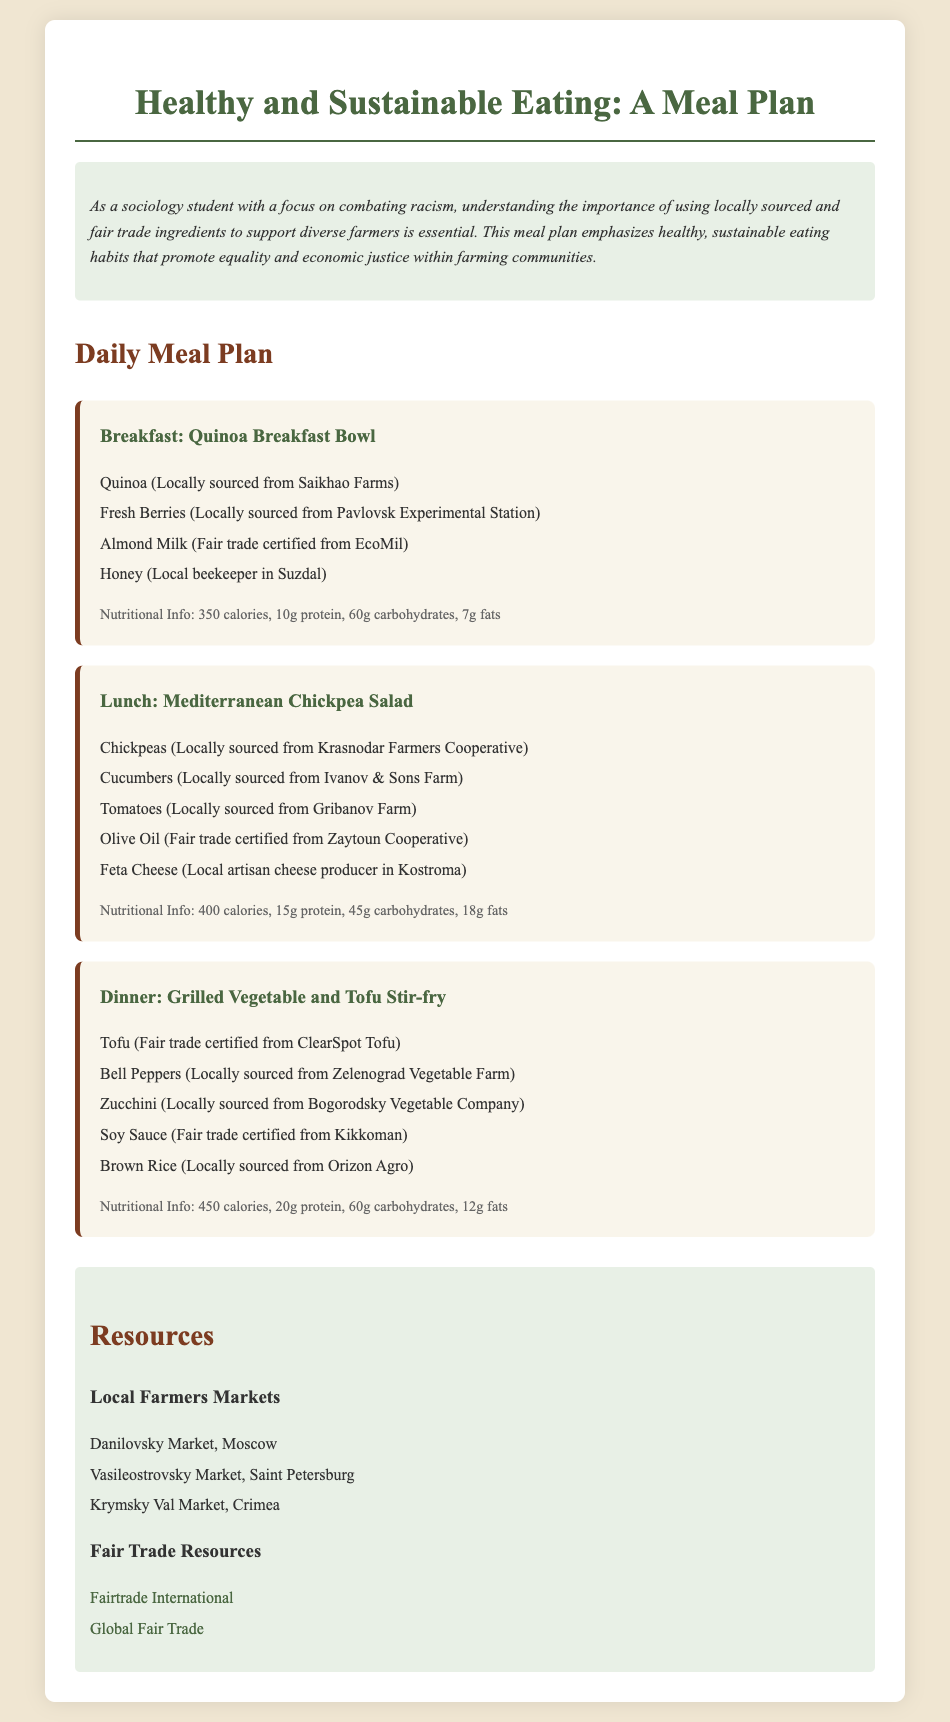What is the breakfast meal? The document specifies that the breakfast meal is a "Quinoa Breakfast Bowl."
Answer: Quinoa Breakfast Bowl Where are the chickpeas sourced from? Chickpeas are locally sourced from the "Krasnodar Farmers Cooperative."
Answer: Krasnodar Farmers Cooperative What is the total calorie content for lunch? The nutritional information states that the Mediterranean Chickpea Salad contains "400 calories."
Answer: 400 calories Which ingredient is fair trade certified in the dinner meal? The document identifies tofu as fair trade certified from "ClearSpot Tofu."
Answer: ClearSpot Tofu What type of salad is included in the lunch meal? The document describes the lunch meal as a "Mediterranean Chickpea Salad."
Answer: Mediterranean Chickpea Salad Which local farm provides the fresh berries? The fresh berries are sourced from "Pavlovsk Experimental Station."
Answer: Pavlovsk Experimental Station How many grams of protein are in the Grilled Vegetable and Tofu Stir-fry? The nutritional information indicates that it contains "20g protein."
Answer: 20g protein What is one of the resources listed for fair trade? The document includes "Fairtrade International" as a fair trade resource.
Answer: Fairtrade International How many local farmers markets are mentioned? The document lists three local farmers markets.
Answer: 3 